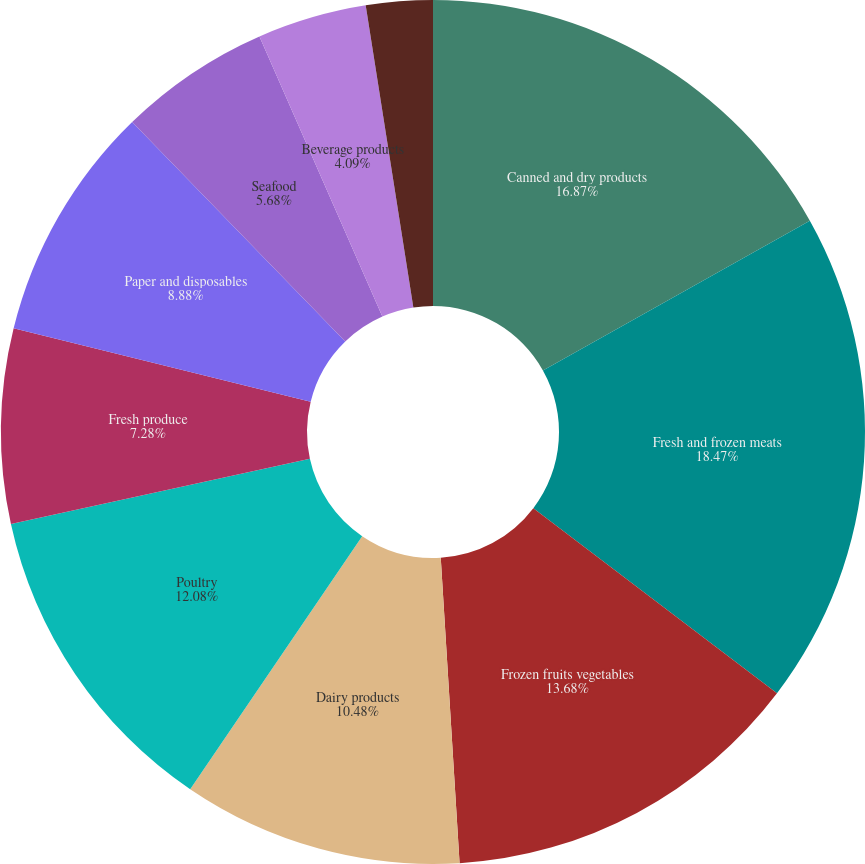Convert chart to OTSL. <chart><loc_0><loc_0><loc_500><loc_500><pie_chart><fcel>Canned and dry products<fcel>Fresh and frozen meats<fcel>Frozen fruits vegetables<fcel>Dairy products<fcel>Poultry<fcel>Fresh produce<fcel>Paper and disposables<fcel>Seafood<fcel>Beverage products<fcel>Janitorial products<nl><fcel>16.87%<fcel>18.47%<fcel>13.68%<fcel>10.48%<fcel>12.08%<fcel>7.28%<fcel>8.88%<fcel>5.68%<fcel>4.09%<fcel>2.49%<nl></chart> 